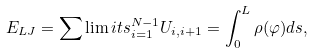<formula> <loc_0><loc_0><loc_500><loc_500>E _ { L J } = \sum \lim i t s _ { i = 1 } ^ { N - 1 } U _ { i , i + 1 } = \int _ { 0 } ^ { L } \rho ( \varphi ) d s ,</formula> 